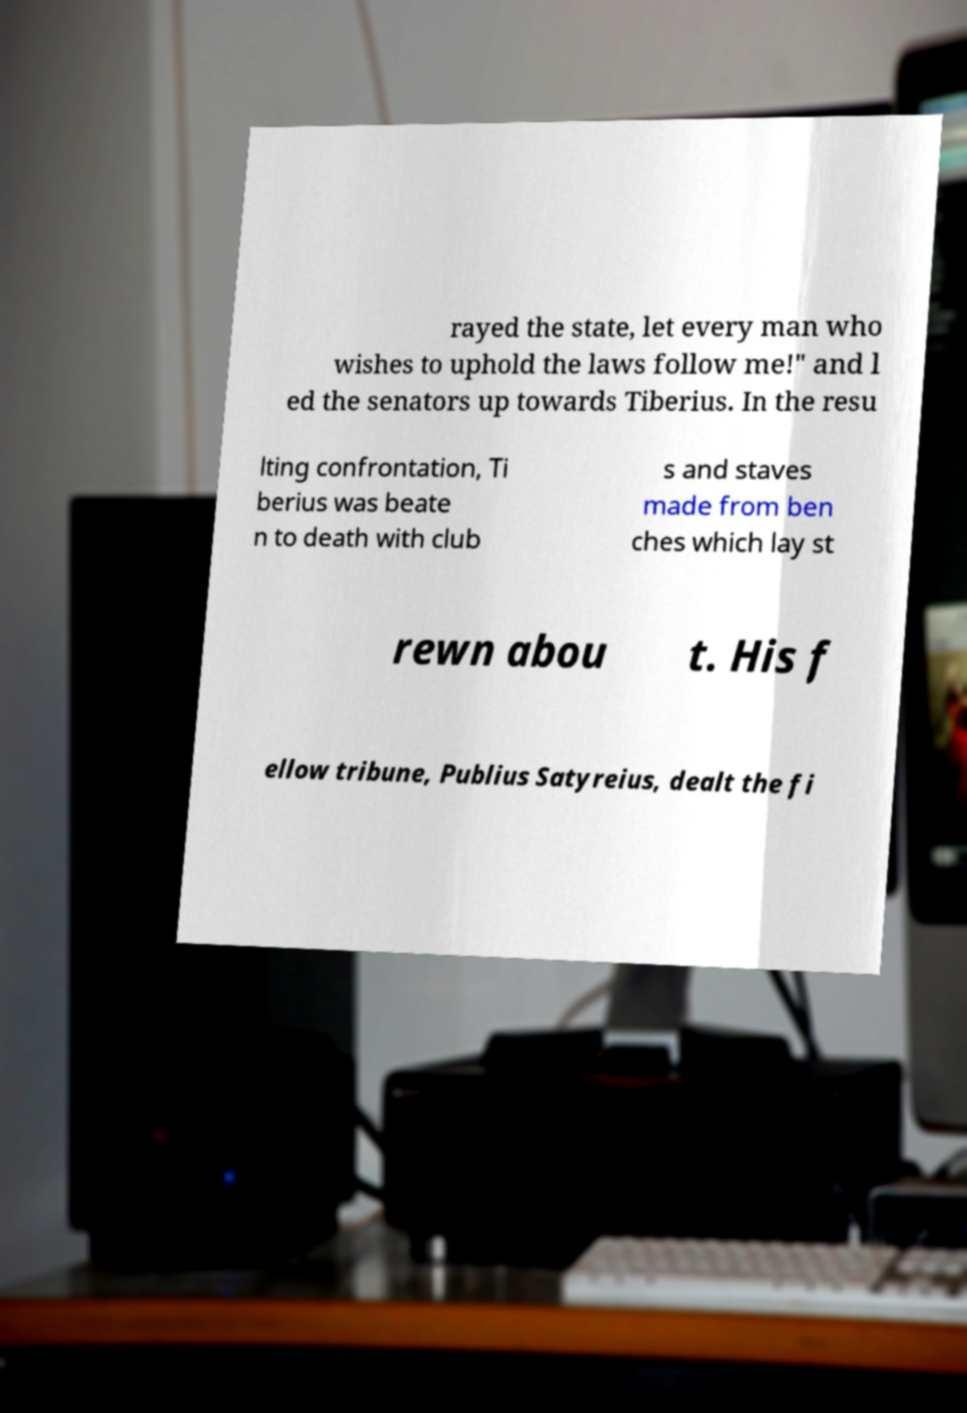Please identify and transcribe the text found in this image. rayed the state, let every man who wishes to uphold the laws follow me!" and l ed the senators up towards Tiberius. In the resu lting confrontation, Ti berius was beate n to death with club s and staves made from ben ches which lay st rewn abou t. His f ellow tribune, Publius Satyreius, dealt the fi 